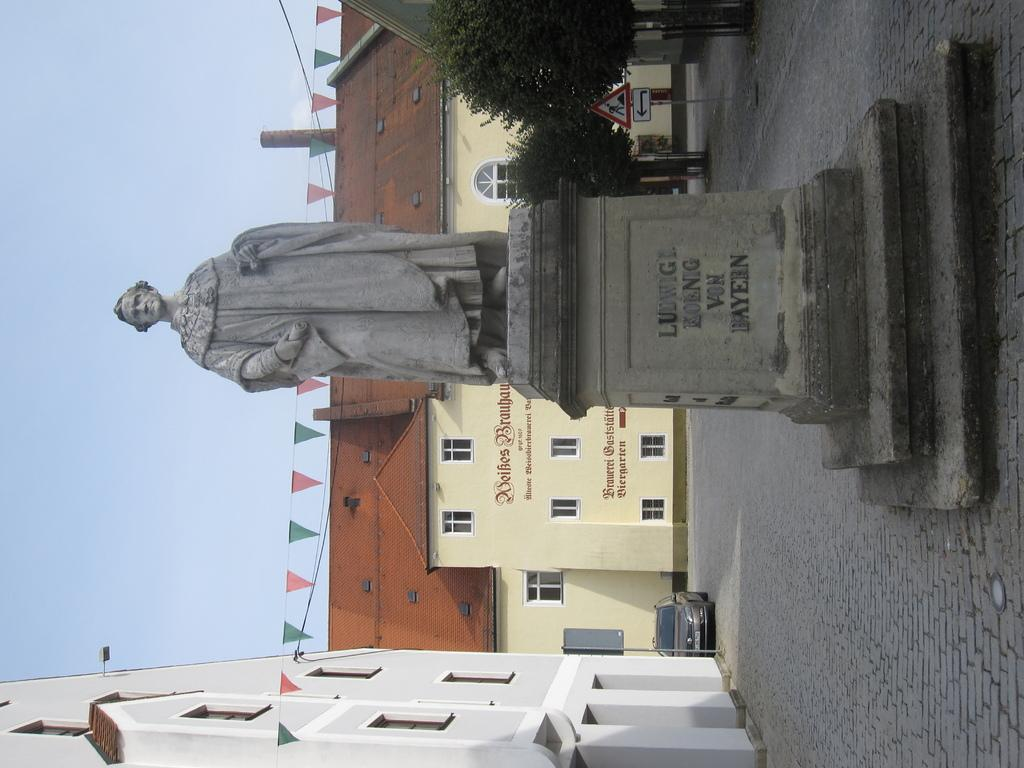<image>
Offer a succinct explanation of the picture presented. A statue of Ludvigi Koenig von Bayern is standing in a plaza. 